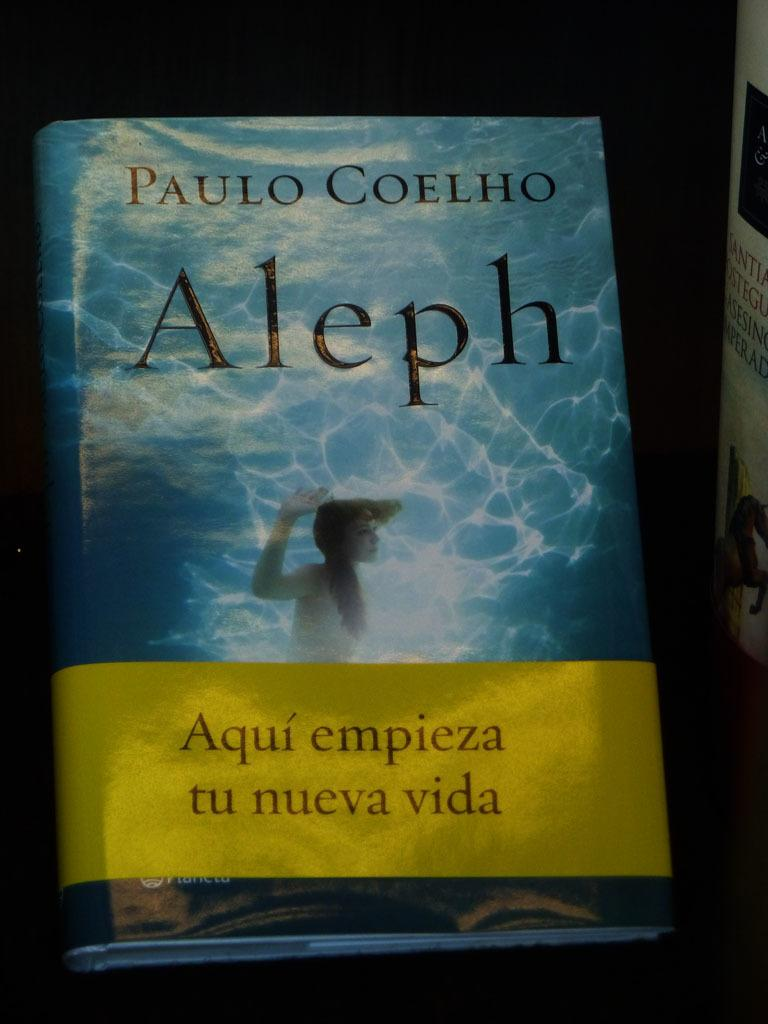<image>
Present a compact description of the photo's key features. A book titled Aleph written by Paulo Coelho. 